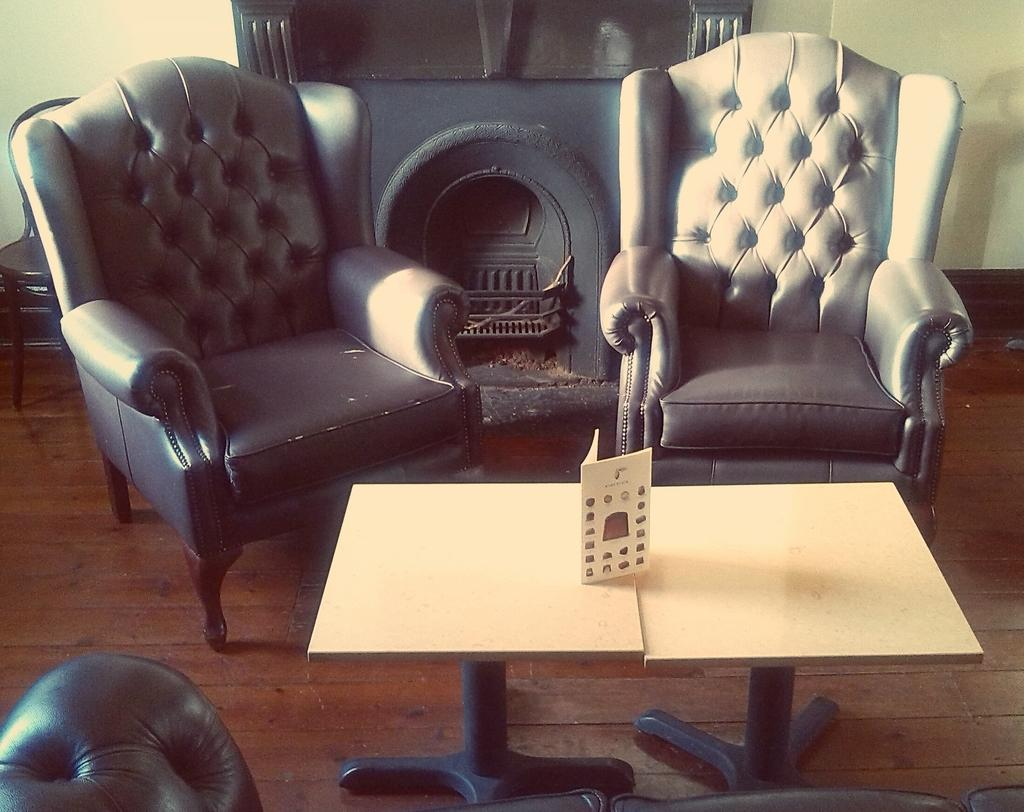What type of furniture is visible in the image? There are chairs and tables in the image. What is placed on the tables? A card is placed on the tables. What can be seen in the background of the image? There is a fireplace and a wall in the background of the image. What type of seating is present at the bottom of the image? A couch is present at the bottom of the image. How many muscles can be seen flexing on the couch in the image? There are no muscles visible in the image; it is a couch, not a person or animal. 